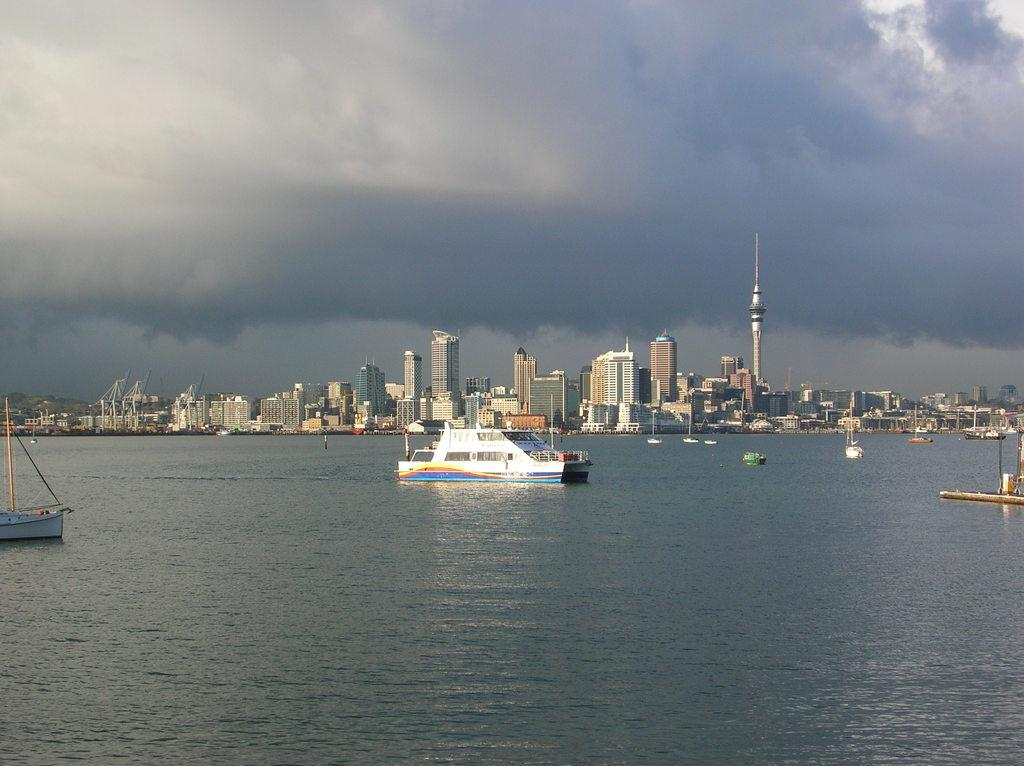What is positioned above the water in the image? There are boats above the water in the image. What can be seen in the distance behind the boats? There are buildings visible in the background. How would you describe the sky in the image? The sky is cloudy in the image. How many snails can be seen crawling on the linen in the image? There are no snails or linen present in the image. Can you tell me how fast the boats are running in the image? The boats are not running in the image; they are floating on the water. 